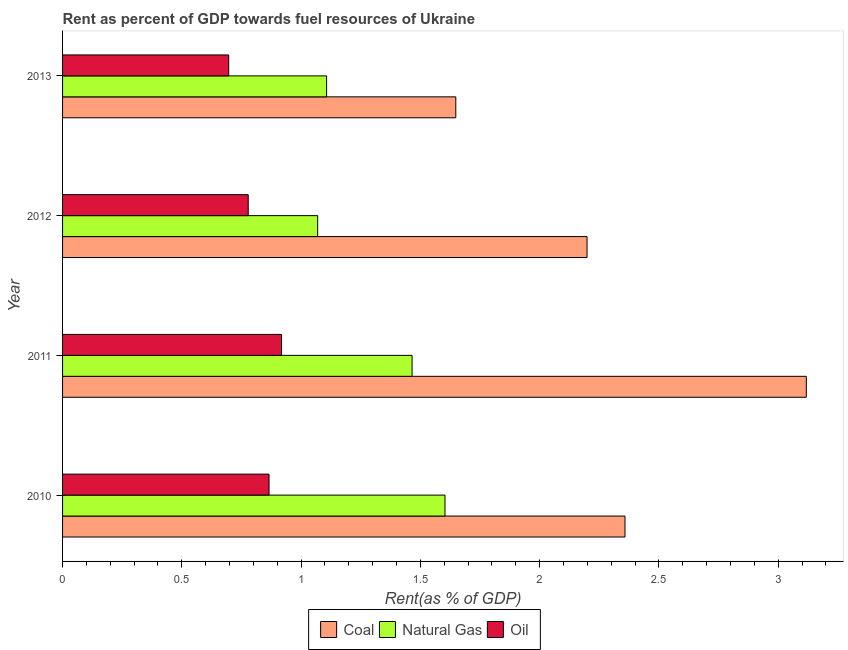How many bars are there on the 2nd tick from the top?
Offer a terse response. 3. How many bars are there on the 4th tick from the bottom?
Provide a short and direct response. 3. In how many cases, is the number of bars for a given year not equal to the number of legend labels?
Offer a terse response. 0. What is the rent towards natural gas in 2012?
Ensure brevity in your answer.  1.07. Across all years, what is the maximum rent towards coal?
Your answer should be compact. 3.12. Across all years, what is the minimum rent towards natural gas?
Your answer should be compact. 1.07. In which year was the rent towards natural gas minimum?
Make the answer very short. 2012. What is the total rent towards oil in the graph?
Ensure brevity in your answer.  3.26. What is the difference between the rent towards coal in 2011 and that in 2012?
Ensure brevity in your answer.  0.92. What is the difference between the rent towards natural gas in 2011 and the rent towards coal in 2013?
Offer a very short reply. -0.18. What is the average rent towards oil per year?
Your answer should be compact. 0.81. In the year 2010, what is the difference between the rent towards coal and rent towards oil?
Keep it short and to the point. 1.49. In how many years, is the rent towards natural gas greater than 1.4 %?
Offer a very short reply. 2. What is the ratio of the rent towards oil in 2011 to that in 2013?
Provide a succinct answer. 1.32. Is the rent towards coal in 2010 less than that in 2011?
Your answer should be compact. Yes. What is the difference between the highest and the second highest rent towards oil?
Provide a succinct answer. 0.05. What is the difference between the highest and the lowest rent towards oil?
Your response must be concise. 0.22. Is the sum of the rent towards natural gas in 2010 and 2012 greater than the maximum rent towards coal across all years?
Your answer should be compact. No. What does the 3rd bar from the top in 2010 represents?
Make the answer very short. Coal. What does the 3rd bar from the bottom in 2011 represents?
Keep it short and to the point. Oil. Is it the case that in every year, the sum of the rent towards coal and rent towards natural gas is greater than the rent towards oil?
Offer a very short reply. Yes. How many bars are there?
Make the answer very short. 12. How many years are there in the graph?
Your answer should be compact. 4. Does the graph contain grids?
Ensure brevity in your answer.  No. Where does the legend appear in the graph?
Offer a terse response. Bottom center. How many legend labels are there?
Offer a terse response. 3. What is the title of the graph?
Your answer should be compact. Rent as percent of GDP towards fuel resources of Ukraine. Does "Primary" appear as one of the legend labels in the graph?
Offer a very short reply. No. What is the label or title of the X-axis?
Your answer should be compact. Rent(as % of GDP). What is the Rent(as % of GDP) in Coal in 2010?
Give a very brief answer. 2.36. What is the Rent(as % of GDP) in Natural Gas in 2010?
Provide a succinct answer. 1.6. What is the Rent(as % of GDP) in Oil in 2010?
Provide a succinct answer. 0.87. What is the Rent(as % of GDP) in Coal in 2011?
Make the answer very short. 3.12. What is the Rent(as % of GDP) in Natural Gas in 2011?
Ensure brevity in your answer.  1.47. What is the Rent(as % of GDP) of Oil in 2011?
Offer a very short reply. 0.92. What is the Rent(as % of GDP) in Coal in 2012?
Keep it short and to the point. 2.2. What is the Rent(as % of GDP) in Natural Gas in 2012?
Offer a very short reply. 1.07. What is the Rent(as % of GDP) in Oil in 2012?
Make the answer very short. 0.78. What is the Rent(as % of GDP) in Coal in 2013?
Your response must be concise. 1.65. What is the Rent(as % of GDP) in Natural Gas in 2013?
Give a very brief answer. 1.11. What is the Rent(as % of GDP) of Oil in 2013?
Give a very brief answer. 0.7. Across all years, what is the maximum Rent(as % of GDP) of Coal?
Your answer should be very brief. 3.12. Across all years, what is the maximum Rent(as % of GDP) of Natural Gas?
Keep it short and to the point. 1.6. Across all years, what is the maximum Rent(as % of GDP) in Oil?
Make the answer very short. 0.92. Across all years, what is the minimum Rent(as % of GDP) of Coal?
Your answer should be compact. 1.65. Across all years, what is the minimum Rent(as % of GDP) in Natural Gas?
Provide a short and direct response. 1.07. Across all years, what is the minimum Rent(as % of GDP) in Oil?
Your answer should be very brief. 0.7. What is the total Rent(as % of GDP) in Coal in the graph?
Provide a short and direct response. 9.32. What is the total Rent(as % of GDP) in Natural Gas in the graph?
Provide a short and direct response. 5.24. What is the total Rent(as % of GDP) in Oil in the graph?
Keep it short and to the point. 3.26. What is the difference between the Rent(as % of GDP) of Coal in 2010 and that in 2011?
Make the answer very short. -0.76. What is the difference between the Rent(as % of GDP) of Natural Gas in 2010 and that in 2011?
Keep it short and to the point. 0.14. What is the difference between the Rent(as % of GDP) in Oil in 2010 and that in 2011?
Give a very brief answer. -0.05. What is the difference between the Rent(as % of GDP) in Coal in 2010 and that in 2012?
Offer a very short reply. 0.16. What is the difference between the Rent(as % of GDP) of Natural Gas in 2010 and that in 2012?
Make the answer very short. 0.53. What is the difference between the Rent(as % of GDP) in Oil in 2010 and that in 2012?
Provide a short and direct response. 0.09. What is the difference between the Rent(as % of GDP) in Coal in 2010 and that in 2013?
Give a very brief answer. 0.71. What is the difference between the Rent(as % of GDP) in Natural Gas in 2010 and that in 2013?
Keep it short and to the point. 0.5. What is the difference between the Rent(as % of GDP) in Oil in 2010 and that in 2013?
Keep it short and to the point. 0.17. What is the difference between the Rent(as % of GDP) of Coal in 2011 and that in 2012?
Ensure brevity in your answer.  0.92. What is the difference between the Rent(as % of GDP) of Natural Gas in 2011 and that in 2012?
Offer a terse response. 0.4. What is the difference between the Rent(as % of GDP) of Oil in 2011 and that in 2012?
Offer a terse response. 0.14. What is the difference between the Rent(as % of GDP) of Coal in 2011 and that in 2013?
Make the answer very short. 1.47. What is the difference between the Rent(as % of GDP) of Natural Gas in 2011 and that in 2013?
Offer a terse response. 0.36. What is the difference between the Rent(as % of GDP) of Oil in 2011 and that in 2013?
Offer a very short reply. 0.22. What is the difference between the Rent(as % of GDP) in Coal in 2012 and that in 2013?
Provide a succinct answer. 0.55. What is the difference between the Rent(as % of GDP) in Natural Gas in 2012 and that in 2013?
Provide a succinct answer. -0.04. What is the difference between the Rent(as % of GDP) in Oil in 2012 and that in 2013?
Your response must be concise. 0.08. What is the difference between the Rent(as % of GDP) in Coal in 2010 and the Rent(as % of GDP) in Natural Gas in 2011?
Keep it short and to the point. 0.89. What is the difference between the Rent(as % of GDP) of Coal in 2010 and the Rent(as % of GDP) of Oil in 2011?
Keep it short and to the point. 1.44. What is the difference between the Rent(as % of GDP) of Natural Gas in 2010 and the Rent(as % of GDP) of Oil in 2011?
Make the answer very short. 0.69. What is the difference between the Rent(as % of GDP) of Coal in 2010 and the Rent(as % of GDP) of Natural Gas in 2012?
Offer a terse response. 1.29. What is the difference between the Rent(as % of GDP) in Coal in 2010 and the Rent(as % of GDP) in Oil in 2012?
Your response must be concise. 1.58. What is the difference between the Rent(as % of GDP) of Natural Gas in 2010 and the Rent(as % of GDP) of Oil in 2012?
Provide a succinct answer. 0.82. What is the difference between the Rent(as % of GDP) in Coal in 2010 and the Rent(as % of GDP) in Natural Gas in 2013?
Give a very brief answer. 1.25. What is the difference between the Rent(as % of GDP) of Coal in 2010 and the Rent(as % of GDP) of Oil in 2013?
Keep it short and to the point. 1.66. What is the difference between the Rent(as % of GDP) in Natural Gas in 2010 and the Rent(as % of GDP) in Oil in 2013?
Offer a terse response. 0.91. What is the difference between the Rent(as % of GDP) in Coal in 2011 and the Rent(as % of GDP) in Natural Gas in 2012?
Offer a terse response. 2.05. What is the difference between the Rent(as % of GDP) of Coal in 2011 and the Rent(as % of GDP) of Oil in 2012?
Ensure brevity in your answer.  2.34. What is the difference between the Rent(as % of GDP) of Natural Gas in 2011 and the Rent(as % of GDP) of Oil in 2012?
Provide a succinct answer. 0.69. What is the difference between the Rent(as % of GDP) of Coal in 2011 and the Rent(as % of GDP) of Natural Gas in 2013?
Your answer should be compact. 2.01. What is the difference between the Rent(as % of GDP) of Coal in 2011 and the Rent(as % of GDP) of Oil in 2013?
Make the answer very short. 2.42. What is the difference between the Rent(as % of GDP) of Natural Gas in 2011 and the Rent(as % of GDP) of Oil in 2013?
Keep it short and to the point. 0.77. What is the difference between the Rent(as % of GDP) in Coal in 2012 and the Rent(as % of GDP) in Natural Gas in 2013?
Your answer should be compact. 1.09. What is the difference between the Rent(as % of GDP) of Coal in 2012 and the Rent(as % of GDP) of Oil in 2013?
Give a very brief answer. 1.5. What is the difference between the Rent(as % of GDP) of Natural Gas in 2012 and the Rent(as % of GDP) of Oil in 2013?
Your answer should be very brief. 0.37. What is the average Rent(as % of GDP) of Coal per year?
Make the answer very short. 2.33. What is the average Rent(as % of GDP) in Natural Gas per year?
Your response must be concise. 1.31. What is the average Rent(as % of GDP) in Oil per year?
Your answer should be very brief. 0.81. In the year 2010, what is the difference between the Rent(as % of GDP) of Coal and Rent(as % of GDP) of Natural Gas?
Provide a succinct answer. 0.75. In the year 2010, what is the difference between the Rent(as % of GDP) in Coal and Rent(as % of GDP) in Oil?
Provide a succinct answer. 1.49. In the year 2010, what is the difference between the Rent(as % of GDP) of Natural Gas and Rent(as % of GDP) of Oil?
Your answer should be very brief. 0.74. In the year 2011, what is the difference between the Rent(as % of GDP) of Coal and Rent(as % of GDP) of Natural Gas?
Offer a terse response. 1.65. In the year 2011, what is the difference between the Rent(as % of GDP) of Coal and Rent(as % of GDP) of Oil?
Provide a succinct answer. 2.2. In the year 2011, what is the difference between the Rent(as % of GDP) of Natural Gas and Rent(as % of GDP) of Oil?
Your response must be concise. 0.55. In the year 2012, what is the difference between the Rent(as % of GDP) in Coal and Rent(as % of GDP) in Natural Gas?
Offer a terse response. 1.13. In the year 2012, what is the difference between the Rent(as % of GDP) of Coal and Rent(as % of GDP) of Oil?
Provide a short and direct response. 1.42. In the year 2012, what is the difference between the Rent(as % of GDP) in Natural Gas and Rent(as % of GDP) in Oil?
Your answer should be compact. 0.29. In the year 2013, what is the difference between the Rent(as % of GDP) of Coal and Rent(as % of GDP) of Natural Gas?
Your answer should be very brief. 0.54. In the year 2013, what is the difference between the Rent(as % of GDP) of Coal and Rent(as % of GDP) of Oil?
Give a very brief answer. 0.95. In the year 2013, what is the difference between the Rent(as % of GDP) in Natural Gas and Rent(as % of GDP) in Oil?
Your response must be concise. 0.41. What is the ratio of the Rent(as % of GDP) of Coal in 2010 to that in 2011?
Provide a short and direct response. 0.76. What is the ratio of the Rent(as % of GDP) of Natural Gas in 2010 to that in 2011?
Offer a terse response. 1.09. What is the ratio of the Rent(as % of GDP) of Oil in 2010 to that in 2011?
Provide a short and direct response. 0.94. What is the ratio of the Rent(as % of GDP) in Coal in 2010 to that in 2012?
Keep it short and to the point. 1.07. What is the ratio of the Rent(as % of GDP) in Natural Gas in 2010 to that in 2012?
Give a very brief answer. 1.5. What is the ratio of the Rent(as % of GDP) of Oil in 2010 to that in 2012?
Provide a short and direct response. 1.11. What is the ratio of the Rent(as % of GDP) of Coal in 2010 to that in 2013?
Make the answer very short. 1.43. What is the ratio of the Rent(as % of GDP) in Natural Gas in 2010 to that in 2013?
Ensure brevity in your answer.  1.45. What is the ratio of the Rent(as % of GDP) in Oil in 2010 to that in 2013?
Your response must be concise. 1.24. What is the ratio of the Rent(as % of GDP) of Coal in 2011 to that in 2012?
Offer a terse response. 1.42. What is the ratio of the Rent(as % of GDP) of Natural Gas in 2011 to that in 2012?
Provide a succinct answer. 1.37. What is the ratio of the Rent(as % of GDP) of Oil in 2011 to that in 2012?
Your answer should be compact. 1.18. What is the ratio of the Rent(as % of GDP) in Coal in 2011 to that in 2013?
Your answer should be compact. 1.89. What is the ratio of the Rent(as % of GDP) of Natural Gas in 2011 to that in 2013?
Keep it short and to the point. 1.32. What is the ratio of the Rent(as % of GDP) in Oil in 2011 to that in 2013?
Offer a very short reply. 1.32. What is the ratio of the Rent(as % of GDP) of Coal in 2012 to that in 2013?
Provide a succinct answer. 1.33. What is the ratio of the Rent(as % of GDP) of Natural Gas in 2012 to that in 2013?
Keep it short and to the point. 0.97. What is the ratio of the Rent(as % of GDP) of Oil in 2012 to that in 2013?
Your response must be concise. 1.12. What is the difference between the highest and the second highest Rent(as % of GDP) in Coal?
Offer a very short reply. 0.76. What is the difference between the highest and the second highest Rent(as % of GDP) in Natural Gas?
Your answer should be compact. 0.14. What is the difference between the highest and the second highest Rent(as % of GDP) of Oil?
Offer a terse response. 0.05. What is the difference between the highest and the lowest Rent(as % of GDP) of Coal?
Ensure brevity in your answer.  1.47. What is the difference between the highest and the lowest Rent(as % of GDP) in Natural Gas?
Make the answer very short. 0.53. What is the difference between the highest and the lowest Rent(as % of GDP) in Oil?
Ensure brevity in your answer.  0.22. 